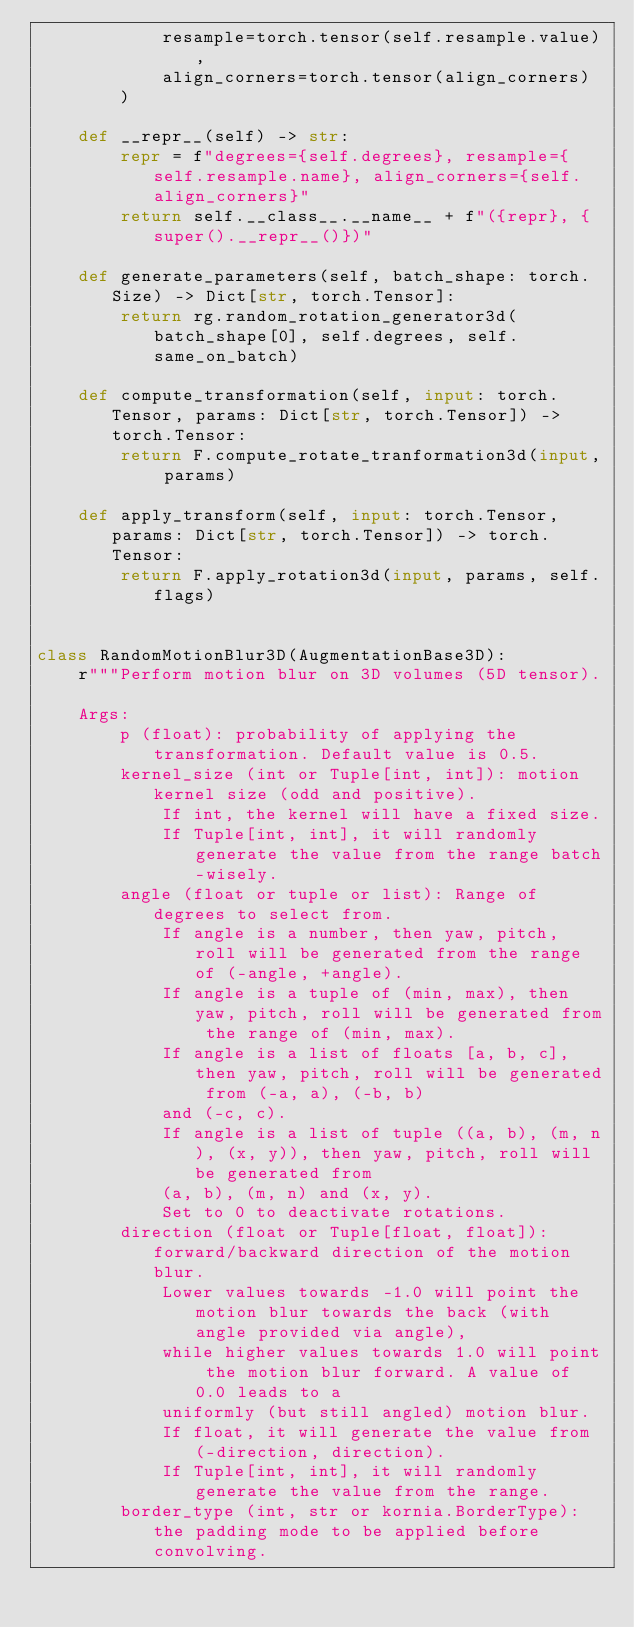<code> <loc_0><loc_0><loc_500><loc_500><_Python_>            resample=torch.tensor(self.resample.value),
            align_corners=torch.tensor(align_corners)
        )

    def __repr__(self) -> str:
        repr = f"degrees={self.degrees}, resample={self.resample.name}, align_corners={self.align_corners}"
        return self.__class__.__name__ + f"({repr}, {super().__repr__()})"

    def generate_parameters(self, batch_shape: torch.Size) -> Dict[str, torch.Tensor]:
        return rg.random_rotation_generator3d(batch_shape[0], self.degrees, self.same_on_batch)

    def compute_transformation(self, input: torch.Tensor, params: Dict[str, torch.Tensor]) -> torch.Tensor:
        return F.compute_rotate_tranformation3d(input, params)

    def apply_transform(self, input: torch.Tensor, params: Dict[str, torch.Tensor]) -> torch.Tensor:
        return F.apply_rotation3d(input, params, self.flags)


class RandomMotionBlur3D(AugmentationBase3D):
    r"""Perform motion blur on 3D volumes (5D tensor).

    Args:
        p (float): probability of applying the transformation. Default value is 0.5.
        kernel_size (int or Tuple[int, int]): motion kernel size (odd and positive).
            If int, the kernel will have a fixed size.
            If Tuple[int, int], it will randomly generate the value from the range batch-wisely.
        angle (float or tuple or list): Range of degrees to select from.
            If angle is a number, then yaw, pitch, roll will be generated from the range of (-angle, +angle).
            If angle is a tuple of (min, max), then yaw, pitch, roll will be generated from the range of (min, max).
            If angle is a list of floats [a, b, c], then yaw, pitch, roll will be generated from (-a, a), (-b, b)
            and (-c, c).
            If angle is a list of tuple ((a, b), (m, n), (x, y)), then yaw, pitch, roll will be generated from
            (a, b), (m, n) and (x, y).
            Set to 0 to deactivate rotations.
        direction (float or Tuple[float, float]): forward/backward direction of the motion blur.
            Lower values towards -1.0 will point the motion blur towards the back (with angle provided via angle),
            while higher values towards 1.0 will point the motion blur forward. A value of 0.0 leads to a
            uniformly (but still angled) motion blur.
            If float, it will generate the value from (-direction, direction).
            If Tuple[int, int], it will randomly generate the value from the range.
        border_type (int, str or kornia.BorderType): the padding mode to be applied before convolving.</code> 